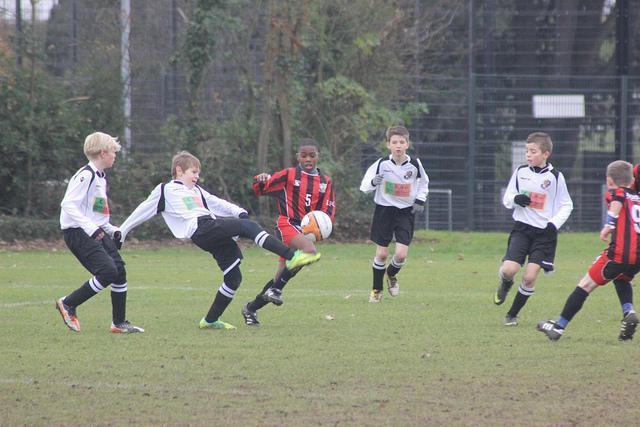How many kids are wearing black and white?
Give a very brief answer. 4. How many people are there?
Give a very brief answer. 6. How many surfboards are visible?
Give a very brief answer. 0. 